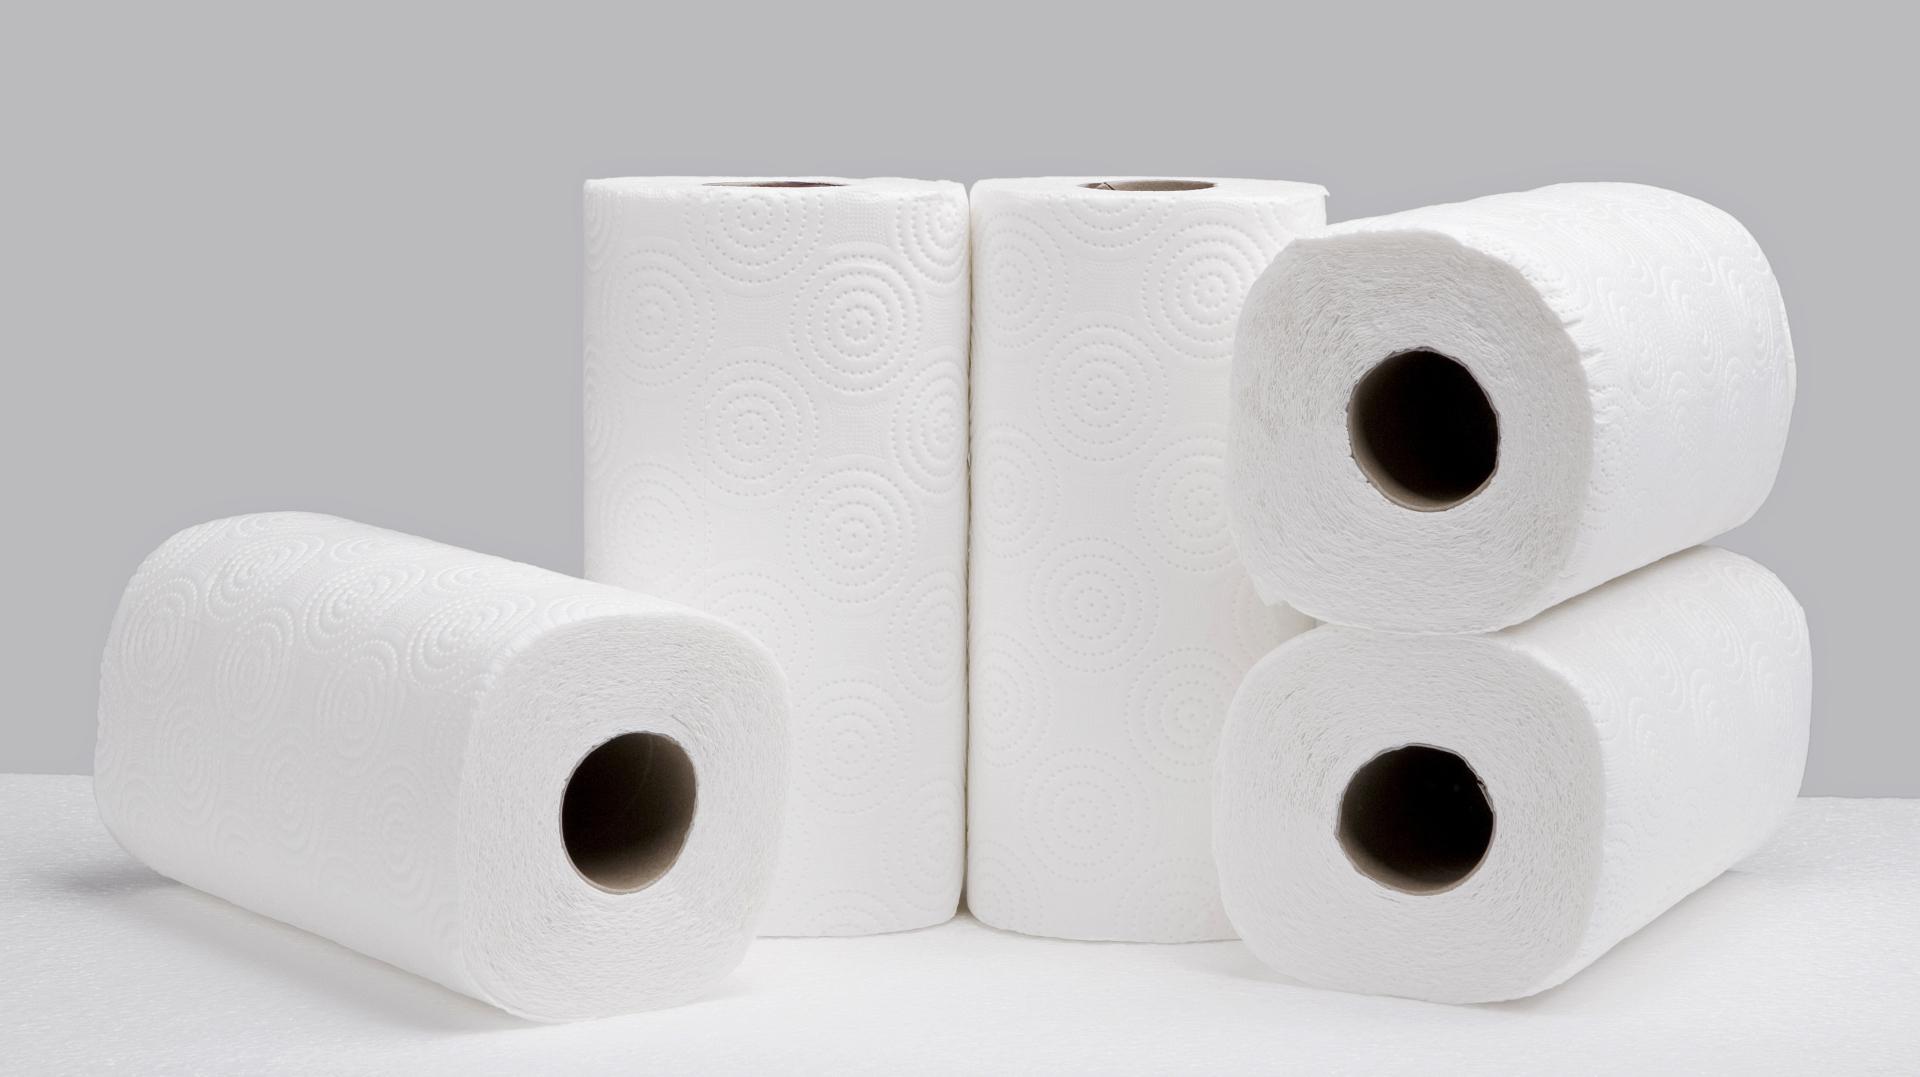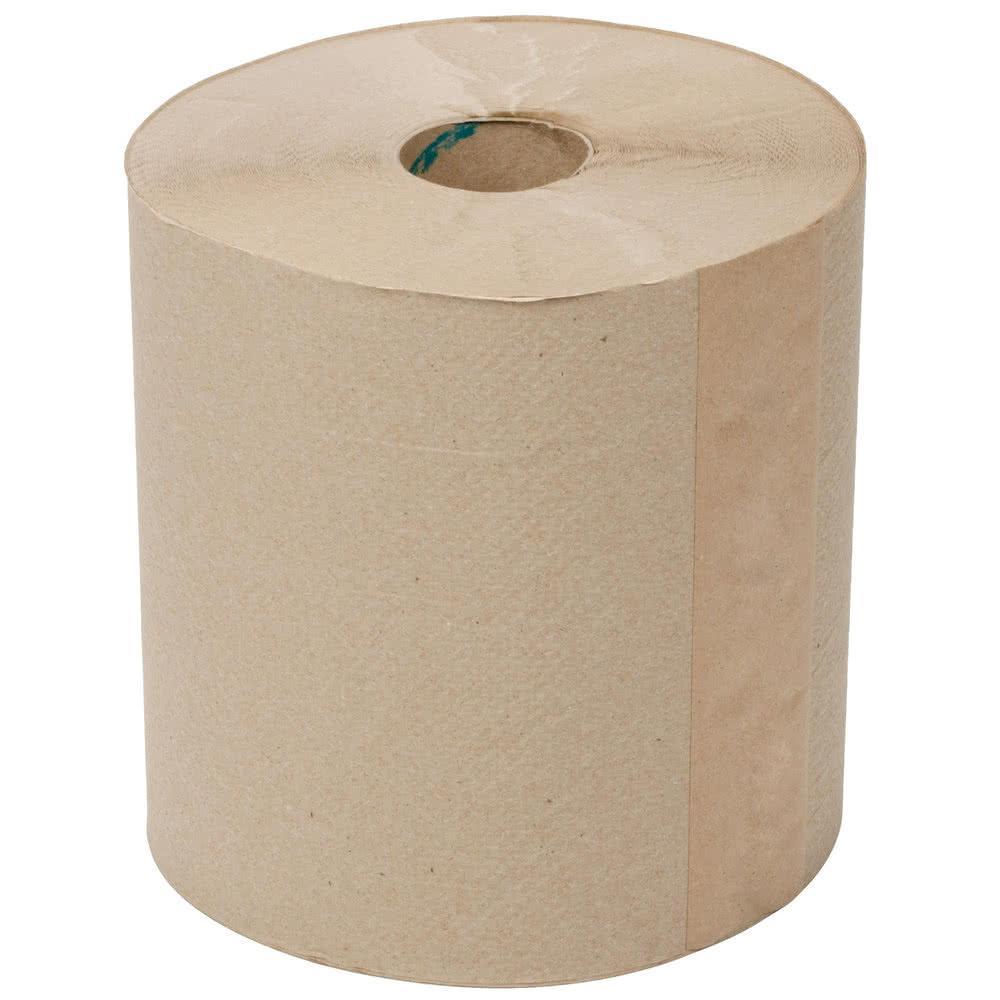The first image is the image on the left, the second image is the image on the right. Examine the images to the left and right. Is the description "An image contains a roll of brown paper towels." accurate? Answer yes or no. Yes. The first image is the image on the left, the second image is the image on the right. Considering the images on both sides, is "An image shows one upright roll of paper towels the color of brown craft paper." valid? Answer yes or no. Yes. 